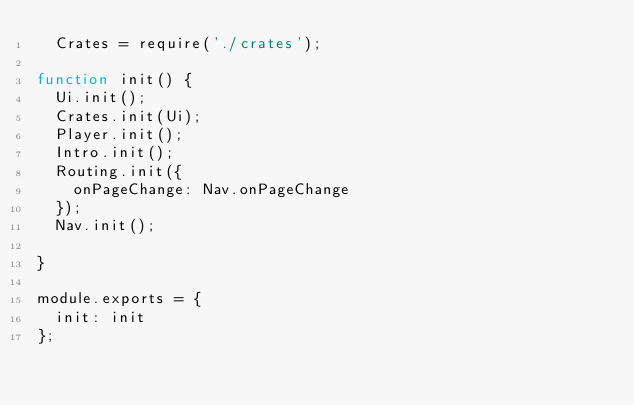Convert code to text. <code><loc_0><loc_0><loc_500><loc_500><_JavaScript_>  Crates = require('./crates');

function init() {
  Ui.init();
  Crates.init(Ui);
  Player.init();
  Intro.init();
  Routing.init({
    onPageChange: Nav.onPageChange
  });
  Nav.init();

}

module.exports = {
  init: init
};
</code> 